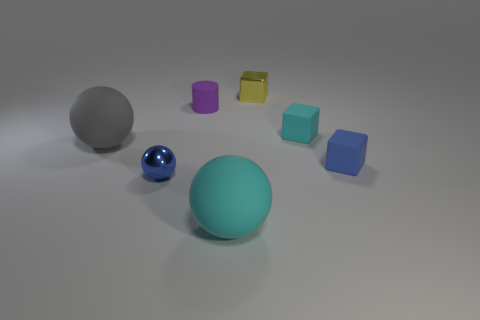Is the number of small cubes to the left of the small cyan matte thing less than the number of tiny purple cylinders?
Ensure brevity in your answer.  No. How many big rubber objects are on the right side of the blue shiny object?
Offer a terse response. 1. There is a metallic object right of the cyan ball; is its shape the same as the small blue thing on the left side of the large cyan matte thing?
Your answer should be compact. No. There is a small matte thing that is both behind the gray rubber object and to the right of the small purple cylinder; what is its shape?
Ensure brevity in your answer.  Cube. The block that is the same material as the small sphere is what size?
Your answer should be very brief. Small. Is the number of big things less than the number of large cyan objects?
Ensure brevity in your answer.  No. What material is the block in front of the cyan thing behind the blue rubber object that is on the right side of the big cyan rubber thing?
Provide a succinct answer. Rubber. Is the blue thing right of the cylinder made of the same material as the tiny blue object to the left of the metallic block?
Offer a terse response. No. There is a object that is in front of the blue matte thing and right of the blue shiny thing; what is its size?
Provide a succinct answer. Large. There is a sphere that is the same size as the gray object; what is its material?
Ensure brevity in your answer.  Rubber. 